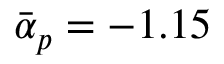Convert formula to latex. <formula><loc_0><loc_0><loc_500><loc_500>\bar { \alpha } _ { p } = - 1 . 1 5</formula> 